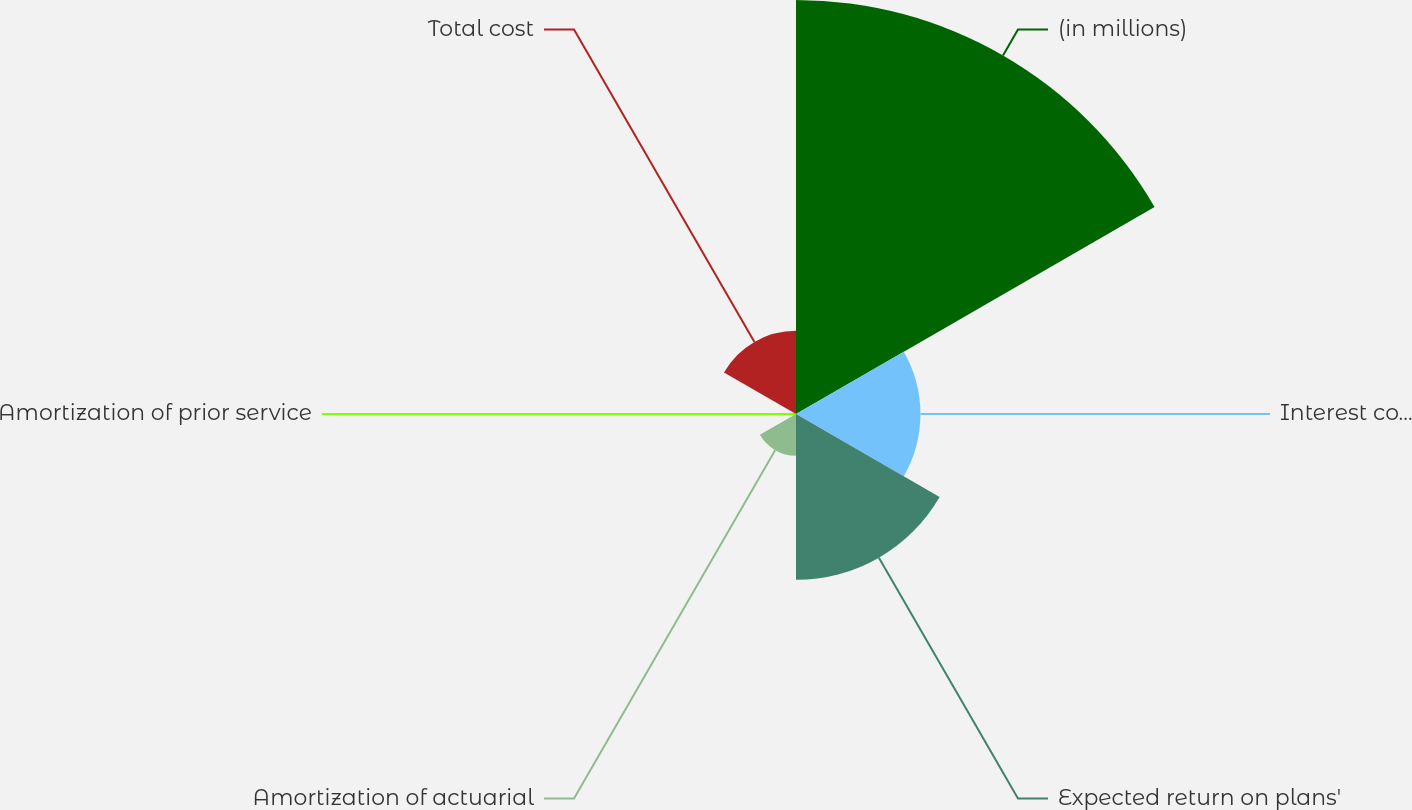Convert chart to OTSL. <chart><loc_0><loc_0><loc_500><loc_500><pie_chart><fcel>(in millions)<fcel>Interest cost on projected<fcel>Expected return on plans'<fcel>Amortization of actuarial<fcel>Amortization of prior service<fcel>Total cost<nl><fcel>49.9%<fcel>15.0%<fcel>19.99%<fcel>5.03%<fcel>0.05%<fcel>10.02%<nl></chart> 